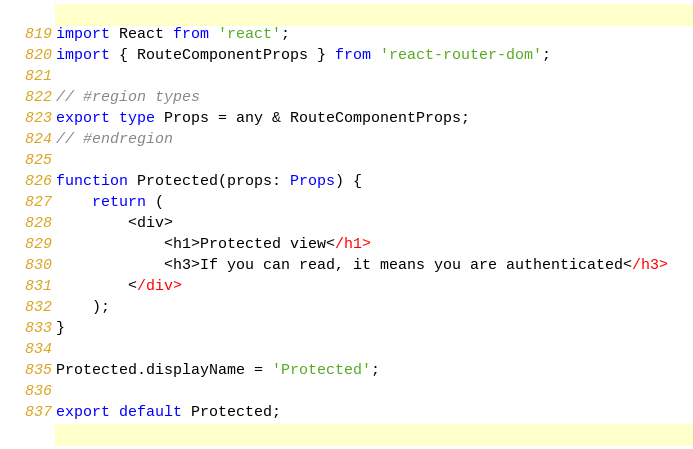Convert code to text. <code><loc_0><loc_0><loc_500><loc_500><_TypeScript_>import React from 'react';
import { RouteComponentProps } from 'react-router-dom';

// #region types
export type Props = any & RouteComponentProps;
// #endregion

function Protected(props: Props) {
    return (
        <div>
            <h1>Protected view</h1>
            <h3>If you can read, it means you are authenticated</h3>
        </div>
    );
}

Protected.displayName = 'Protected';

export default Protected;
</code> 